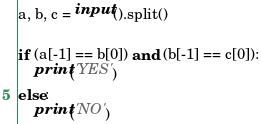<code> <loc_0><loc_0><loc_500><loc_500><_Python_>a, b, c = input().split()

if (a[-1] == b[0]) and (b[-1] == c[0]):
    print('YES')
else:
    print('NO')
</code> 